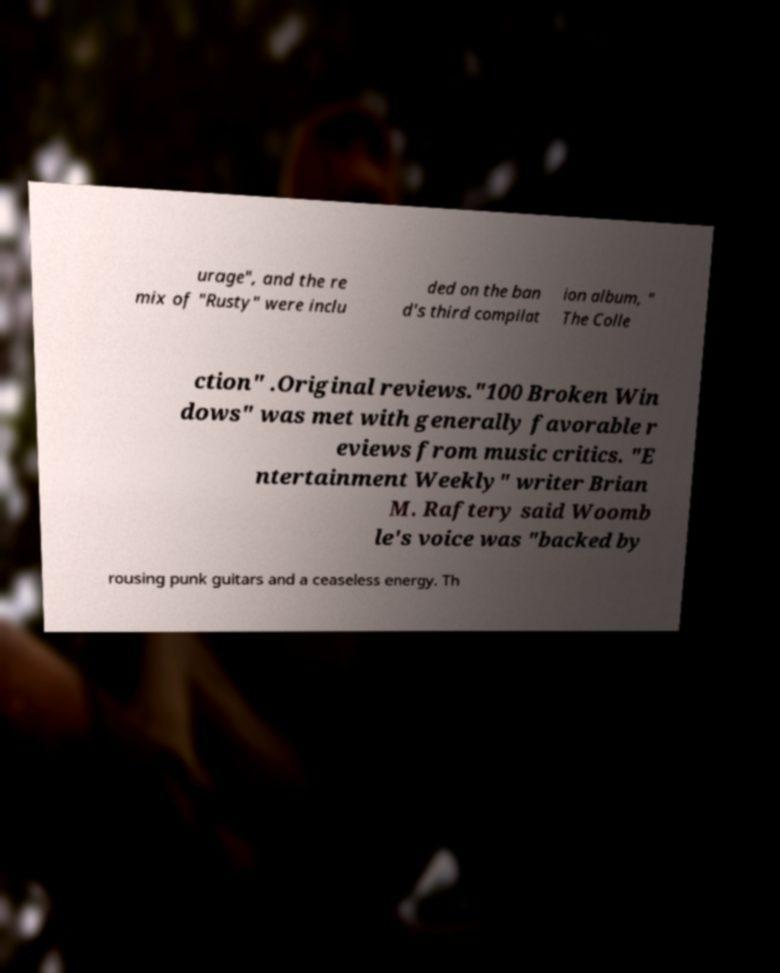Please identify and transcribe the text found in this image. urage", and the re mix of "Rusty" were inclu ded on the ban d's third compilat ion album, " The Colle ction" .Original reviews."100 Broken Win dows" was met with generally favorable r eviews from music critics. "E ntertainment Weekly" writer Brian M. Raftery said Woomb le's voice was "backed by rousing punk guitars and a ceaseless energy. Th 